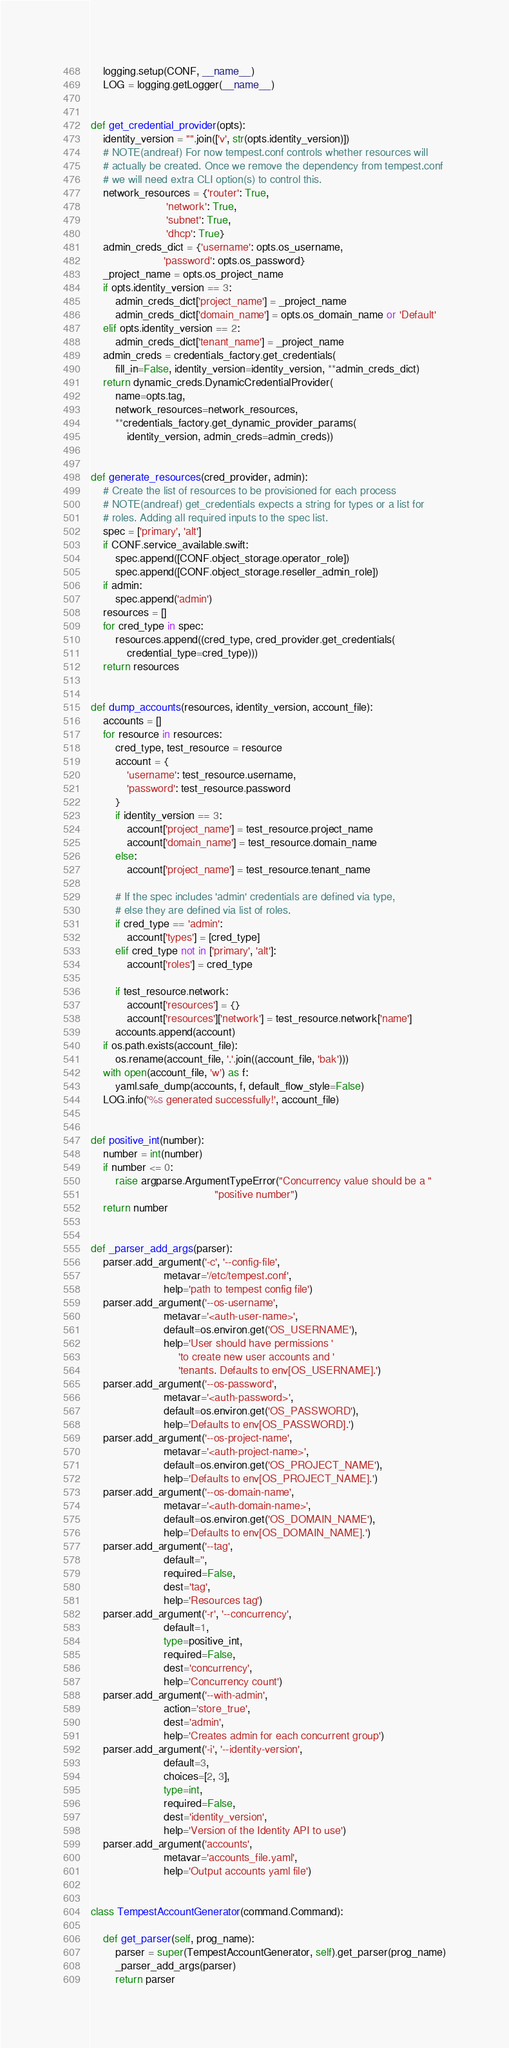<code> <loc_0><loc_0><loc_500><loc_500><_Python_>    logging.setup(CONF, __name__)
    LOG = logging.getLogger(__name__)


def get_credential_provider(opts):
    identity_version = "".join(['v', str(opts.identity_version)])
    # NOTE(andreaf) For now tempest.conf controls whether resources will
    # actually be created. Once we remove the dependency from tempest.conf
    # we will need extra CLI option(s) to control this.
    network_resources = {'router': True,
                         'network': True,
                         'subnet': True,
                         'dhcp': True}
    admin_creds_dict = {'username': opts.os_username,
                        'password': opts.os_password}
    _project_name = opts.os_project_name
    if opts.identity_version == 3:
        admin_creds_dict['project_name'] = _project_name
        admin_creds_dict['domain_name'] = opts.os_domain_name or 'Default'
    elif opts.identity_version == 2:
        admin_creds_dict['tenant_name'] = _project_name
    admin_creds = credentials_factory.get_credentials(
        fill_in=False, identity_version=identity_version, **admin_creds_dict)
    return dynamic_creds.DynamicCredentialProvider(
        name=opts.tag,
        network_resources=network_resources,
        **credentials_factory.get_dynamic_provider_params(
            identity_version, admin_creds=admin_creds))


def generate_resources(cred_provider, admin):
    # Create the list of resources to be provisioned for each process
    # NOTE(andreaf) get_credentials expects a string for types or a list for
    # roles. Adding all required inputs to the spec list.
    spec = ['primary', 'alt']
    if CONF.service_available.swift:
        spec.append([CONF.object_storage.operator_role])
        spec.append([CONF.object_storage.reseller_admin_role])
    if admin:
        spec.append('admin')
    resources = []
    for cred_type in spec:
        resources.append((cred_type, cred_provider.get_credentials(
            credential_type=cred_type)))
    return resources


def dump_accounts(resources, identity_version, account_file):
    accounts = []
    for resource in resources:
        cred_type, test_resource = resource
        account = {
            'username': test_resource.username,
            'password': test_resource.password
        }
        if identity_version == 3:
            account['project_name'] = test_resource.project_name
            account['domain_name'] = test_resource.domain_name
        else:
            account['project_name'] = test_resource.tenant_name

        # If the spec includes 'admin' credentials are defined via type,
        # else they are defined via list of roles.
        if cred_type == 'admin':
            account['types'] = [cred_type]
        elif cred_type not in ['primary', 'alt']:
            account['roles'] = cred_type

        if test_resource.network:
            account['resources'] = {}
            account['resources']['network'] = test_resource.network['name']
        accounts.append(account)
    if os.path.exists(account_file):
        os.rename(account_file, '.'.join((account_file, 'bak')))
    with open(account_file, 'w') as f:
        yaml.safe_dump(accounts, f, default_flow_style=False)
    LOG.info('%s generated successfully!', account_file)


def positive_int(number):
    number = int(number)
    if number <= 0:
        raise argparse.ArgumentTypeError("Concurrency value should be a "
                                         "positive number")
    return number


def _parser_add_args(parser):
    parser.add_argument('-c', '--config-file',
                        metavar='/etc/tempest.conf',
                        help='path to tempest config file')
    parser.add_argument('--os-username',
                        metavar='<auth-user-name>',
                        default=os.environ.get('OS_USERNAME'),
                        help='User should have permissions '
                             'to create new user accounts and '
                             'tenants. Defaults to env[OS_USERNAME].')
    parser.add_argument('--os-password',
                        metavar='<auth-password>',
                        default=os.environ.get('OS_PASSWORD'),
                        help='Defaults to env[OS_PASSWORD].')
    parser.add_argument('--os-project-name',
                        metavar='<auth-project-name>',
                        default=os.environ.get('OS_PROJECT_NAME'),
                        help='Defaults to env[OS_PROJECT_NAME].')
    parser.add_argument('--os-domain-name',
                        metavar='<auth-domain-name>',
                        default=os.environ.get('OS_DOMAIN_NAME'),
                        help='Defaults to env[OS_DOMAIN_NAME].')
    parser.add_argument('--tag',
                        default='',
                        required=False,
                        dest='tag',
                        help='Resources tag')
    parser.add_argument('-r', '--concurrency',
                        default=1,
                        type=positive_int,
                        required=False,
                        dest='concurrency',
                        help='Concurrency count')
    parser.add_argument('--with-admin',
                        action='store_true',
                        dest='admin',
                        help='Creates admin for each concurrent group')
    parser.add_argument('-i', '--identity-version',
                        default=3,
                        choices=[2, 3],
                        type=int,
                        required=False,
                        dest='identity_version',
                        help='Version of the Identity API to use')
    parser.add_argument('accounts',
                        metavar='accounts_file.yaml',
                        help='Output accounts yaml file')


class TempestAccountGenerator(command.Command):

    def get_parser(self, prog_name):
        parser = super(TempestAccountGenerator, self).get_parser(prog_name)
        _parser_add_args(parser)
        return parser
</code> 